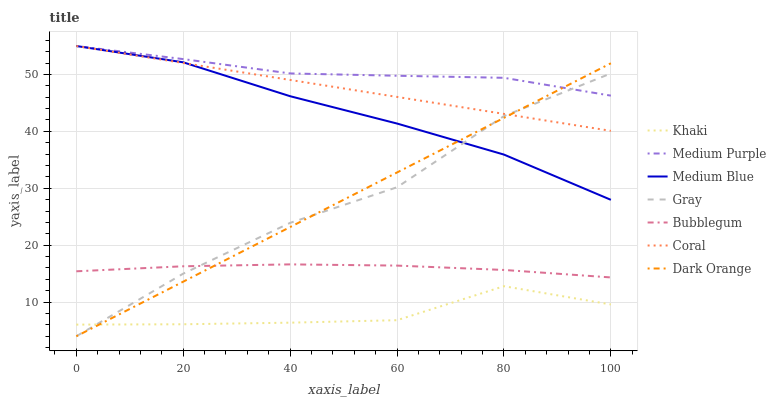Does Dark Orange have the minimum area under the curve?
Answer yes or no. No. Does Dark Orange have the maximum area under the curve?
Answer yes or no. No. Is Khaki the smoothest?
Answer yes or no. No. Is Khaki the roughest?
Answer yes or no. No. Does Khaki have the lowest value?
Answer yes or no. No. Does Dark Orange have the highest value?
Answer yes or no. No. Is Bubblegum less than Medium Purple?
Answer yes or no. Yes. Is Medium Purple greater than Bubblegum?
Answer yes or no. Yes. Does Bubblegum intersect Medium Purple?
Answer yes or no. No. 